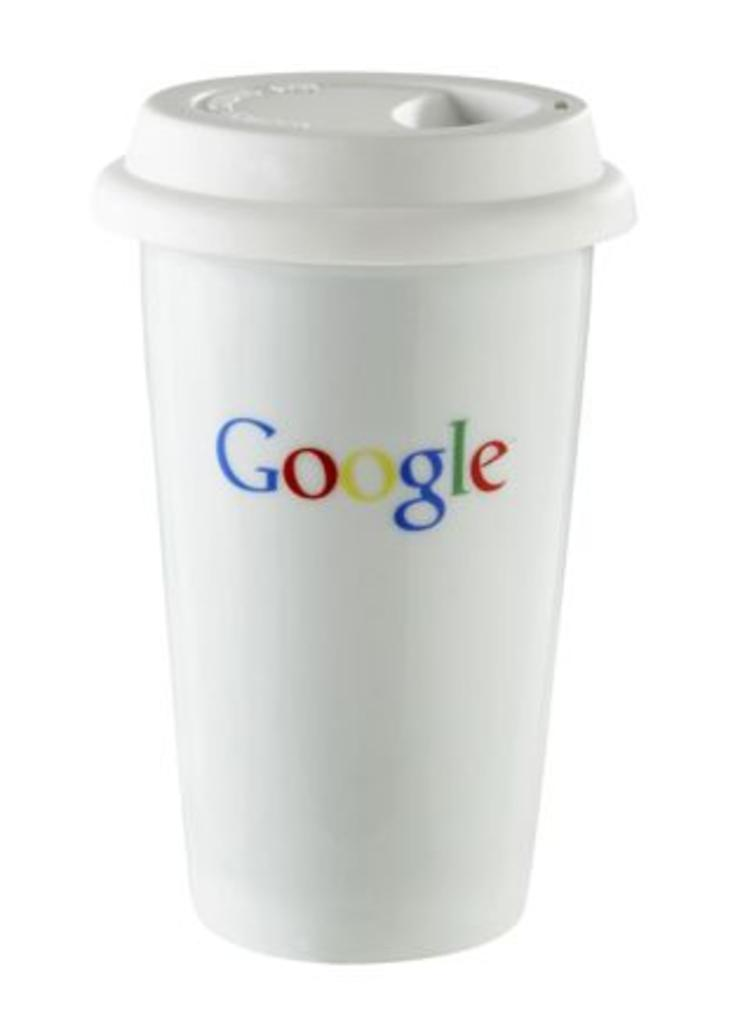<image>
Give a short and clear explanation of the subsequent image. A white coffee cup that displays the name Google 